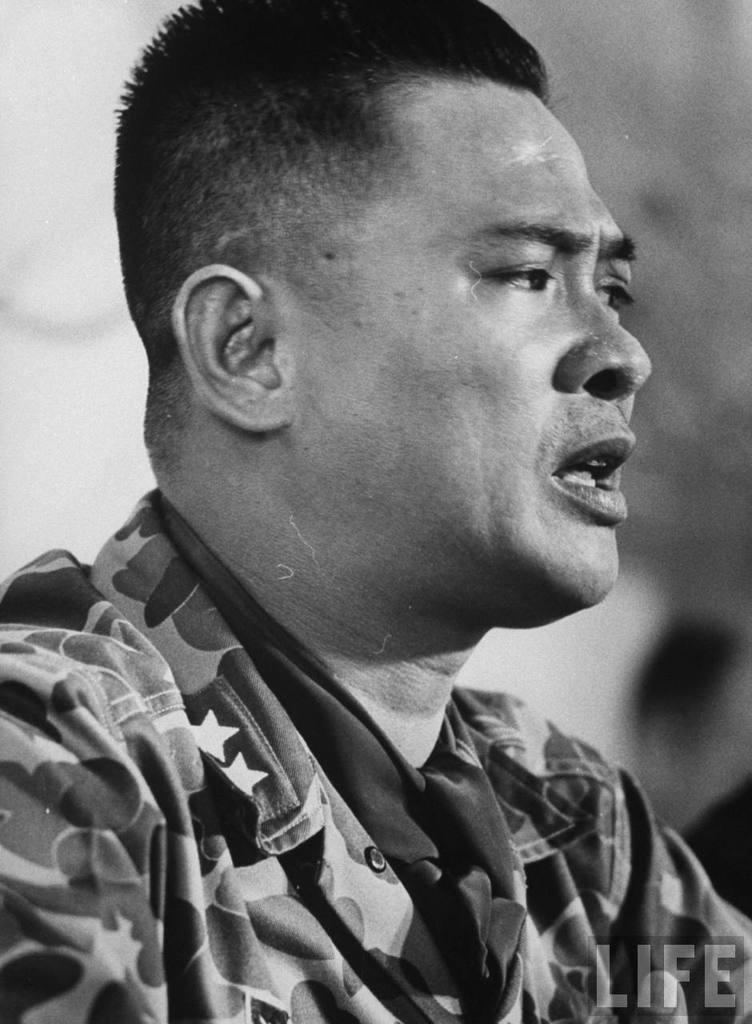Could you give a brief overview of what you see in this image? In this picture we can see a person and in the background we can see it is blurry, in the bottom right we can see some text on it. 